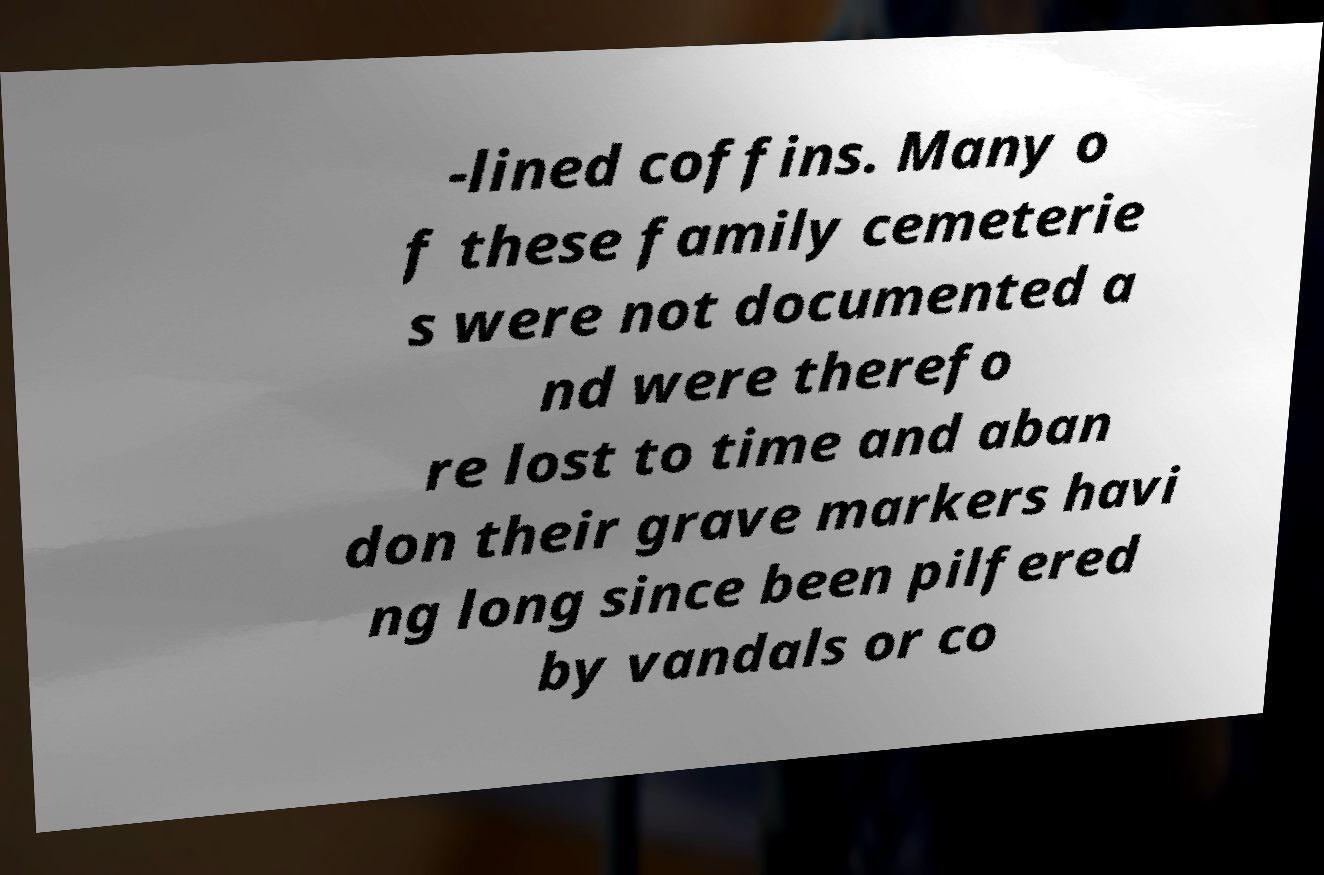Can you read and provide the text displayed in the image?This photo seems to have some interesting text. Can you extract and type it out for me? -lined coffins. Many o f these family cemeterie s were not documented a nd were therefo re lost to time and aban don their grave markers havi ng long since been pilfered by vandals or co 